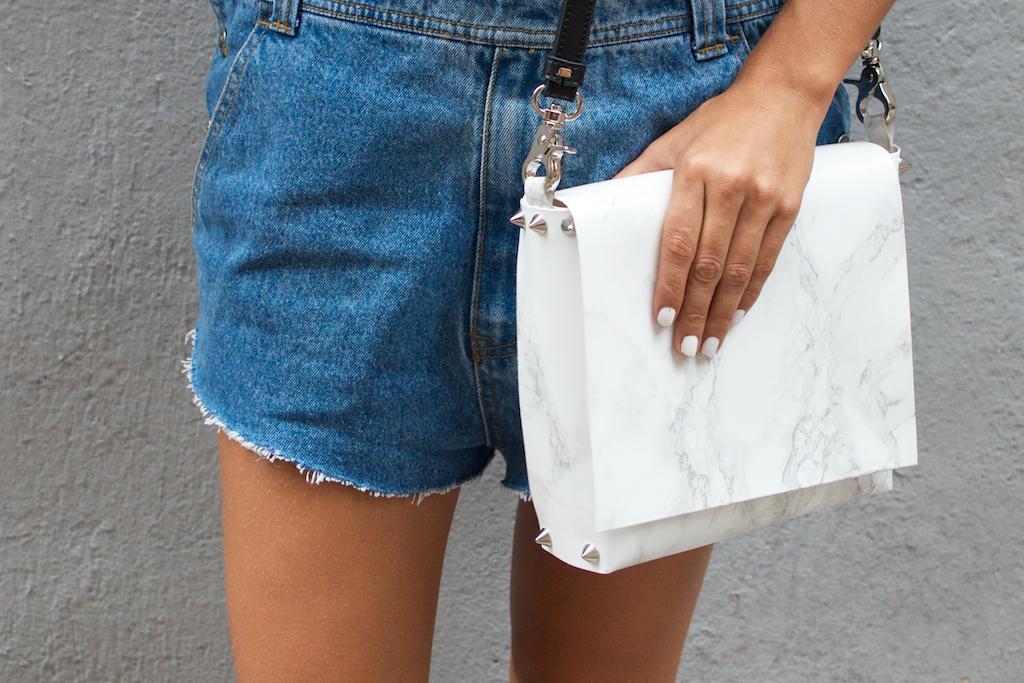Can you describe this image briefly? In the image there is a person's legs with blue jeans short. Holding a white wallet with black strip. Behind the person there is a grey color wall. 